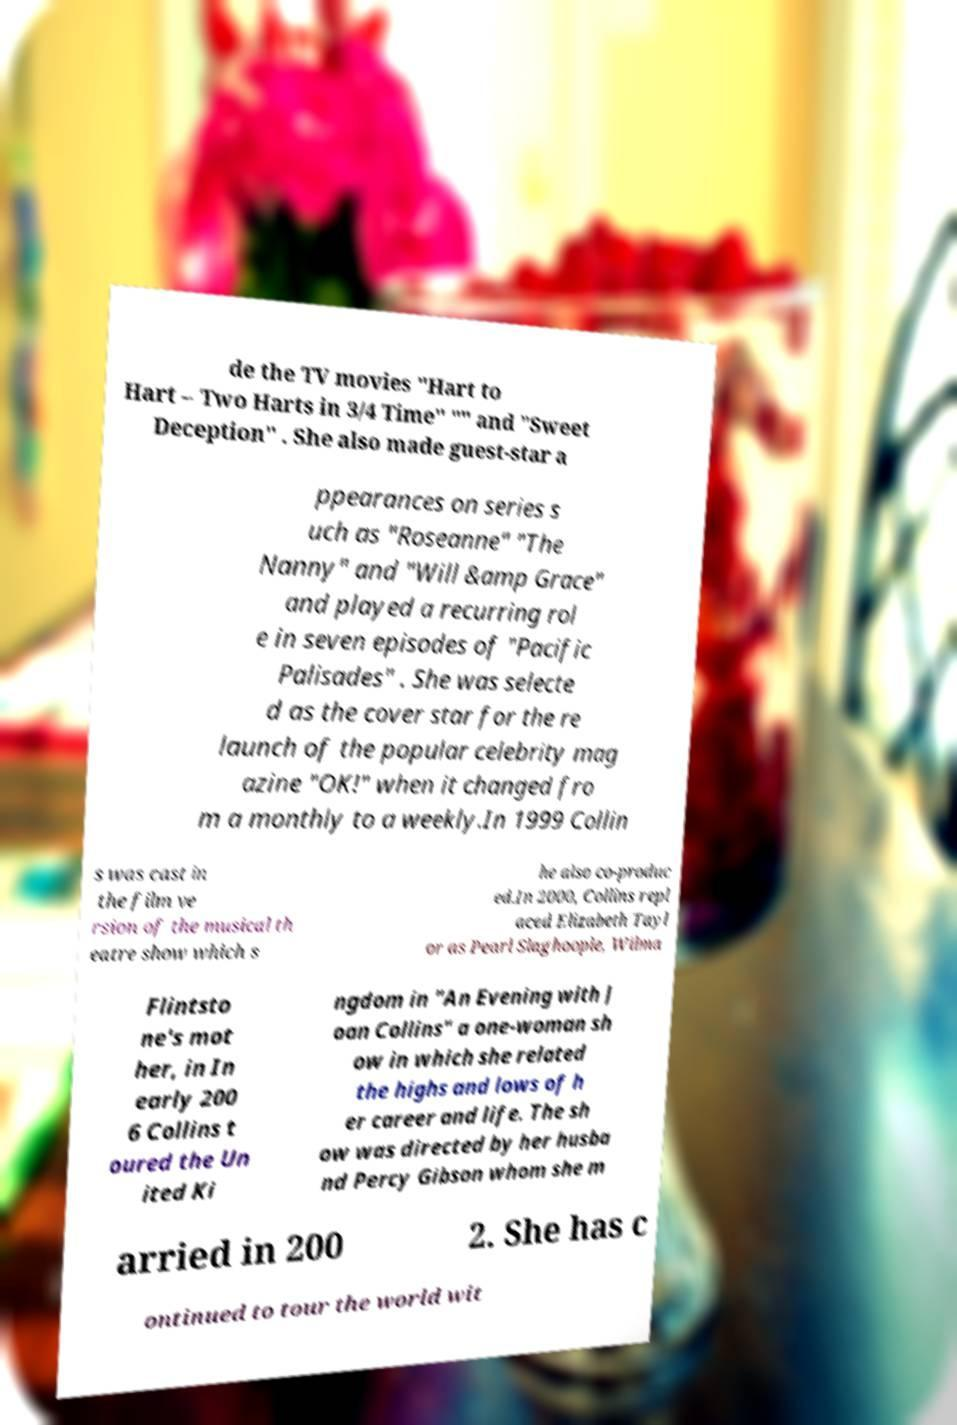What messages or text are displayed in this image? I need them in a readable, typed format. de the TV movies "Hart to Hart – Two Harts in 3/4 Time" "" and "Sweet Deception" . She also made guest-star a ppearances on series s uch as "Roseanne" "The Nanny" and "Will &amp Grace" and played a recurring rol e in seven episodes of "Pacific Palisades" . She was selecte d as the cover star for the re launch of the popular celebrity mag azine "OK!" when it changed fro m a monthly to a weekly.In 1999 Collin s was cast in the film ve rsion of the musical th eatre show which s he also co-produc ed.In 2000, Collins repl aced Elizabeth Tayl or as Pearl Slaghoople, Wilma Flintsto ne's mot her, in In early 200 6 Collins t oured the Un ited Ki ngdom in "An Evening with J oan Collins" a one-woman sh ow in which she related the highs and lows of h er career and life. The sh ow was directed by her husba nd Percy Gibson whom she m arried in 200 2. She has c ontinued to tour the world wit 